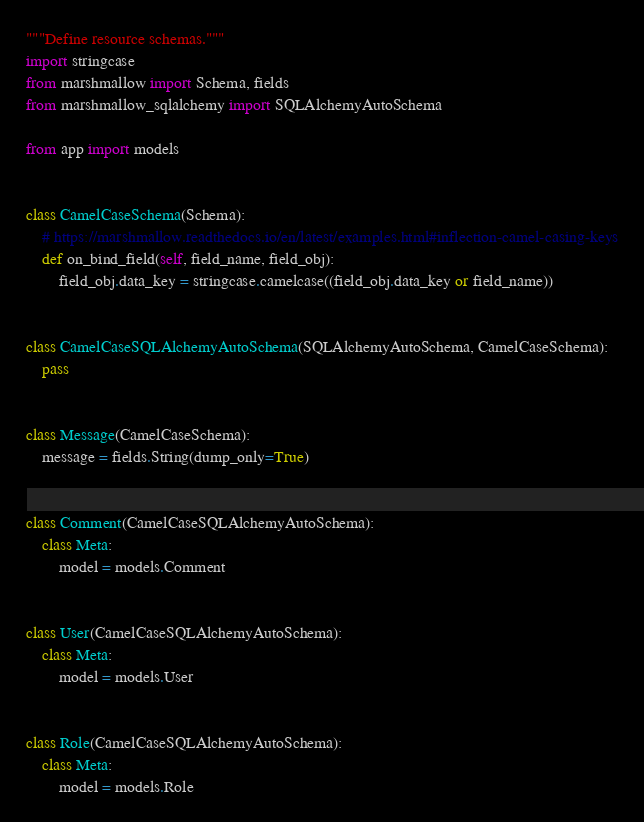<code> <loc_0><loc_0><loc_500><loc_500><_Python_>"""Define resource schemas."""
import stringcase
from marshmallow import Schema, fields
from marshmallow_sqlalchemy import SQLAlchemyAutoSchema

from app import models


class CamelCaseSchema(Schema):
    # https://marshmallow.readthedocs.io/en/latest/examples.html#inflection-camel-casing-keys
    def on_bind_field(self, field_name, field_obj):
        field_obj.data_key = stringcase.camelcase((field_obj.data_key or field_name))


class CamelCaseSQLAlchemyAutoSchema(SQLAlchemyAutoSchema, CamelCaseSchema):
    pass


class Message(CamelCaseSchema):
    message = fields.String(dump_only=True)


class Comment(CamelCaseSQLAlchemyAutoSchema):
    class Meta:
        model = models.Comment


class User(CamelCaseSQLAlchemyAutoSchema):
    class Meta:
        model = models.User


class Role(CamelCaseSQLAlchemyAutoSchema):
    class Meta:
        model = models.Role
</code> 